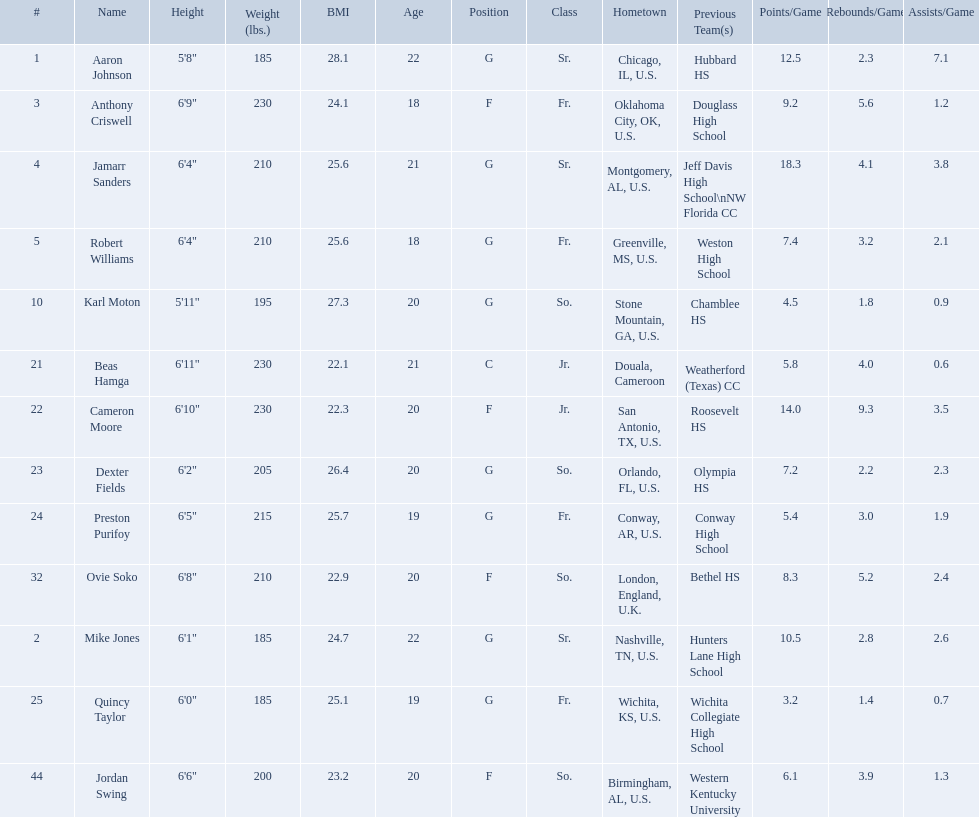Which are all of the players? Aaron Johnson, Anthony Criswell, Jamarr Sanders, Robert Williams, Karl Moton, Beas Hamga, Cameron Moore, Dexter Fields, Preston Purifoy, Ovie Soko, Mike Jones, Quincy Taylor, Jordan Swing. Which players are from a country outside of the u.s.? Beas Hamga, Ovie Soko. Aside from soko, who else is not from the u.s.? Beas Hamga. 